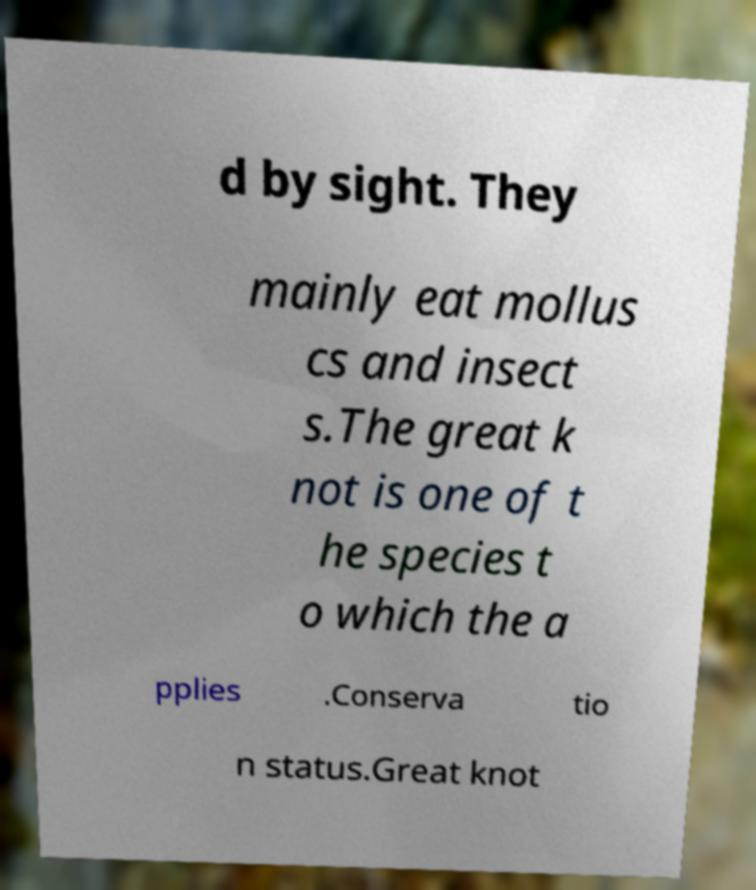Please identify and transcribe the text found in this image. d by sight. They mainly eat mollus cs and insect s.The great k not is one of t he species t o which the a pplies .Conserva tio n status.Great knot 